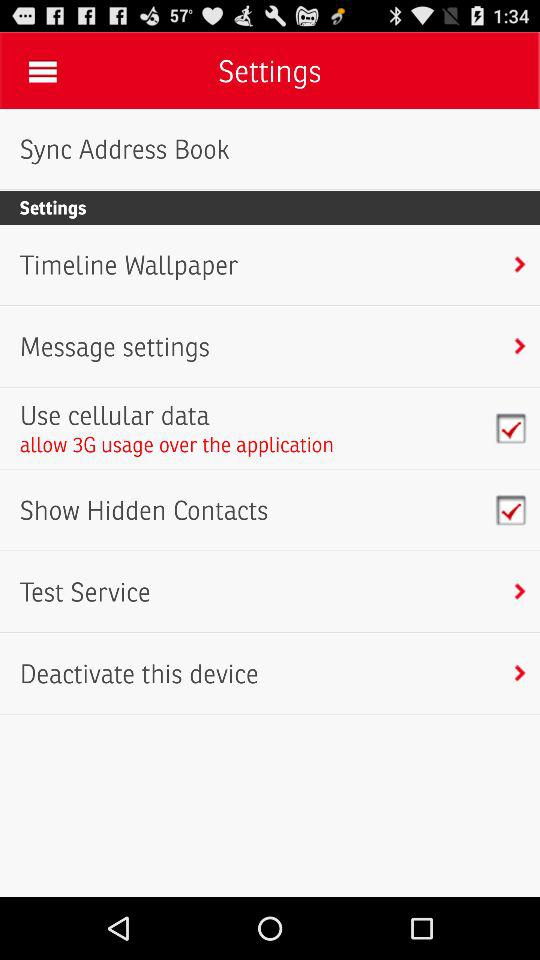What is the status of "Show Hidden Contacts"? The status of "Show Hidden Contacts" is "on". 